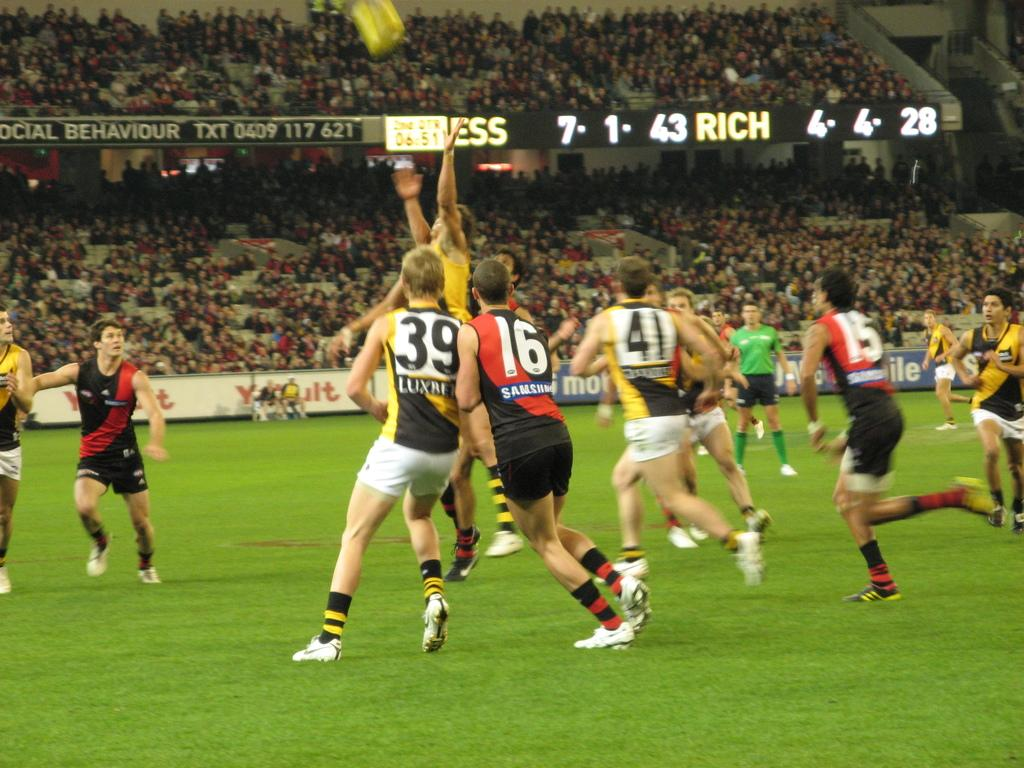<image>
Give a short and clear explanation of the subsequent image. Athletes on a field are wearing jersey numbers 39 and 16, among others. 